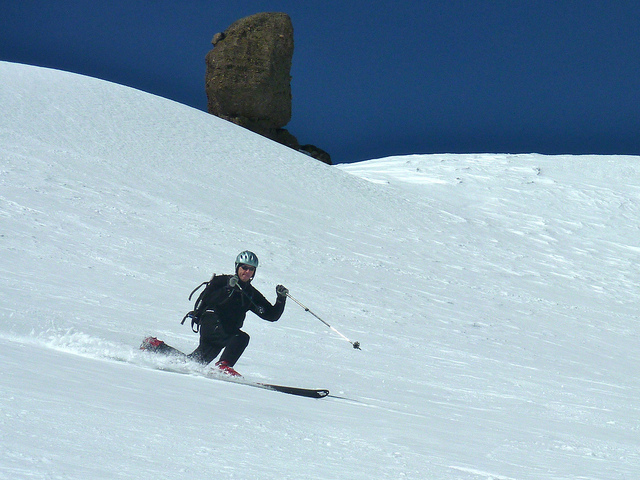<image>How fast is the person going? It is unanswerable how fast the person is going. However, some suggest the person may be going very fast. How fast is the person going? I don't know how fast the person is going. It can be very fast, fast, or very. 